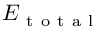<formula> <loc_0><loc_0><loc_500><loc_500>E _ { t o t a l }</formula> 